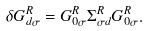Convert formula to latex. <formula><loc_0><loc_0><loc_500><loc_500>\delta G _ { d \sigma } ^ { R } = G _ { 0 \sigma } ^ { R } \Sigma _ { \sigma d } ^ { R } G _ { 0 \sigma } ^ { R } .</formula> 